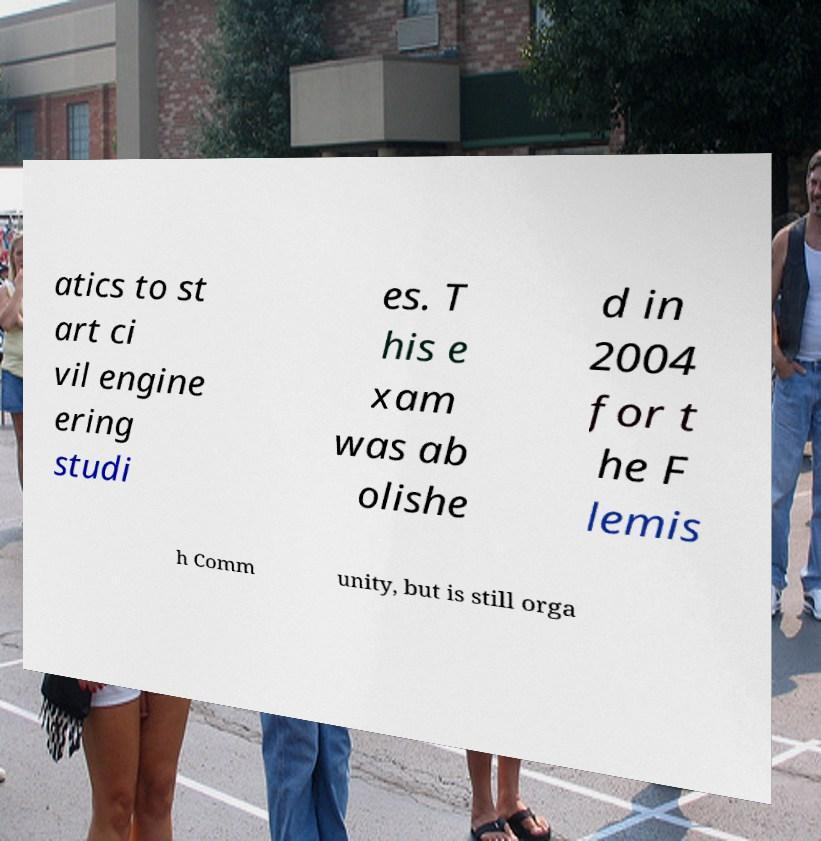Can you accurately transcribe the text from the provided image for me? atics to st art ci vil engine ering studi es. T his e xam was ab olishe d in 2004 for t he F lemis h Comm unity, but is still orga 